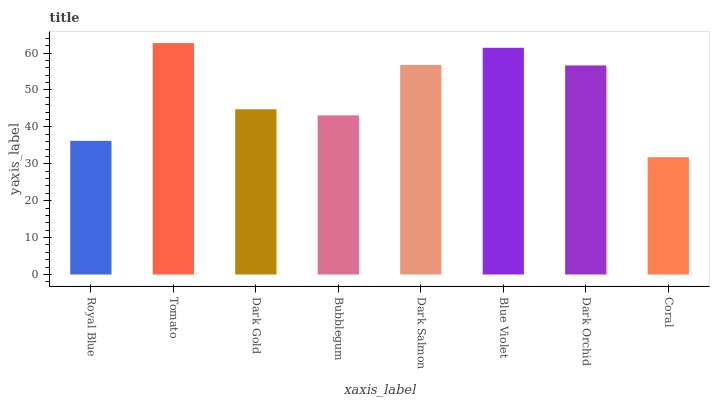Is Dark Gold the minimum?
Answer yes or no. No. Is Dark Gold the maximum?
Answer yes or no. No. Is Tomato greater than Dark Gold?
Answer yes or no. Yes. Is Dark Gold less than Tomato?
Answer yes or no. Yes. Is Dark Gold greater than Tomato?
Answer yes or no. No. Is Tomato less than Dark Gold?
Answer yes or no. No. Is Dark Orchid the high median?
Answer yes or no. Yes. Is Dark Gold the low median?
Answer yes or no. Yes. Is Bubblegum the high median?
Answer yes or no. No. Is Bubblegum the low median?
Answer yes or no. No. 